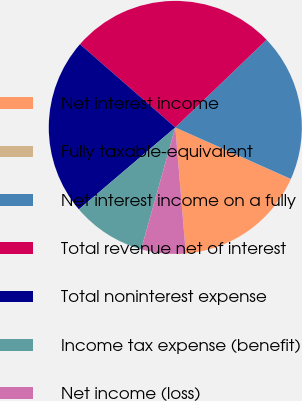<chart> <loc_0><loc_0><loc_500><loc_500><pie_chart><fcel>Net interest income<fcel>Fully taxable-equivalent<fcel>Net interest income on a fully<fcel>Total revenue net of interest<fcel>Total noninterest expense<fcel>Income tax expense (benefit)<fcel>Net income (loss)<nl><fcel>16.98%<fcel>0.02%<fcel>18.86%<fcel>26.4%<fcel>22.63%<fcel>9.44%<fcel>5.67%<nl></chart> 